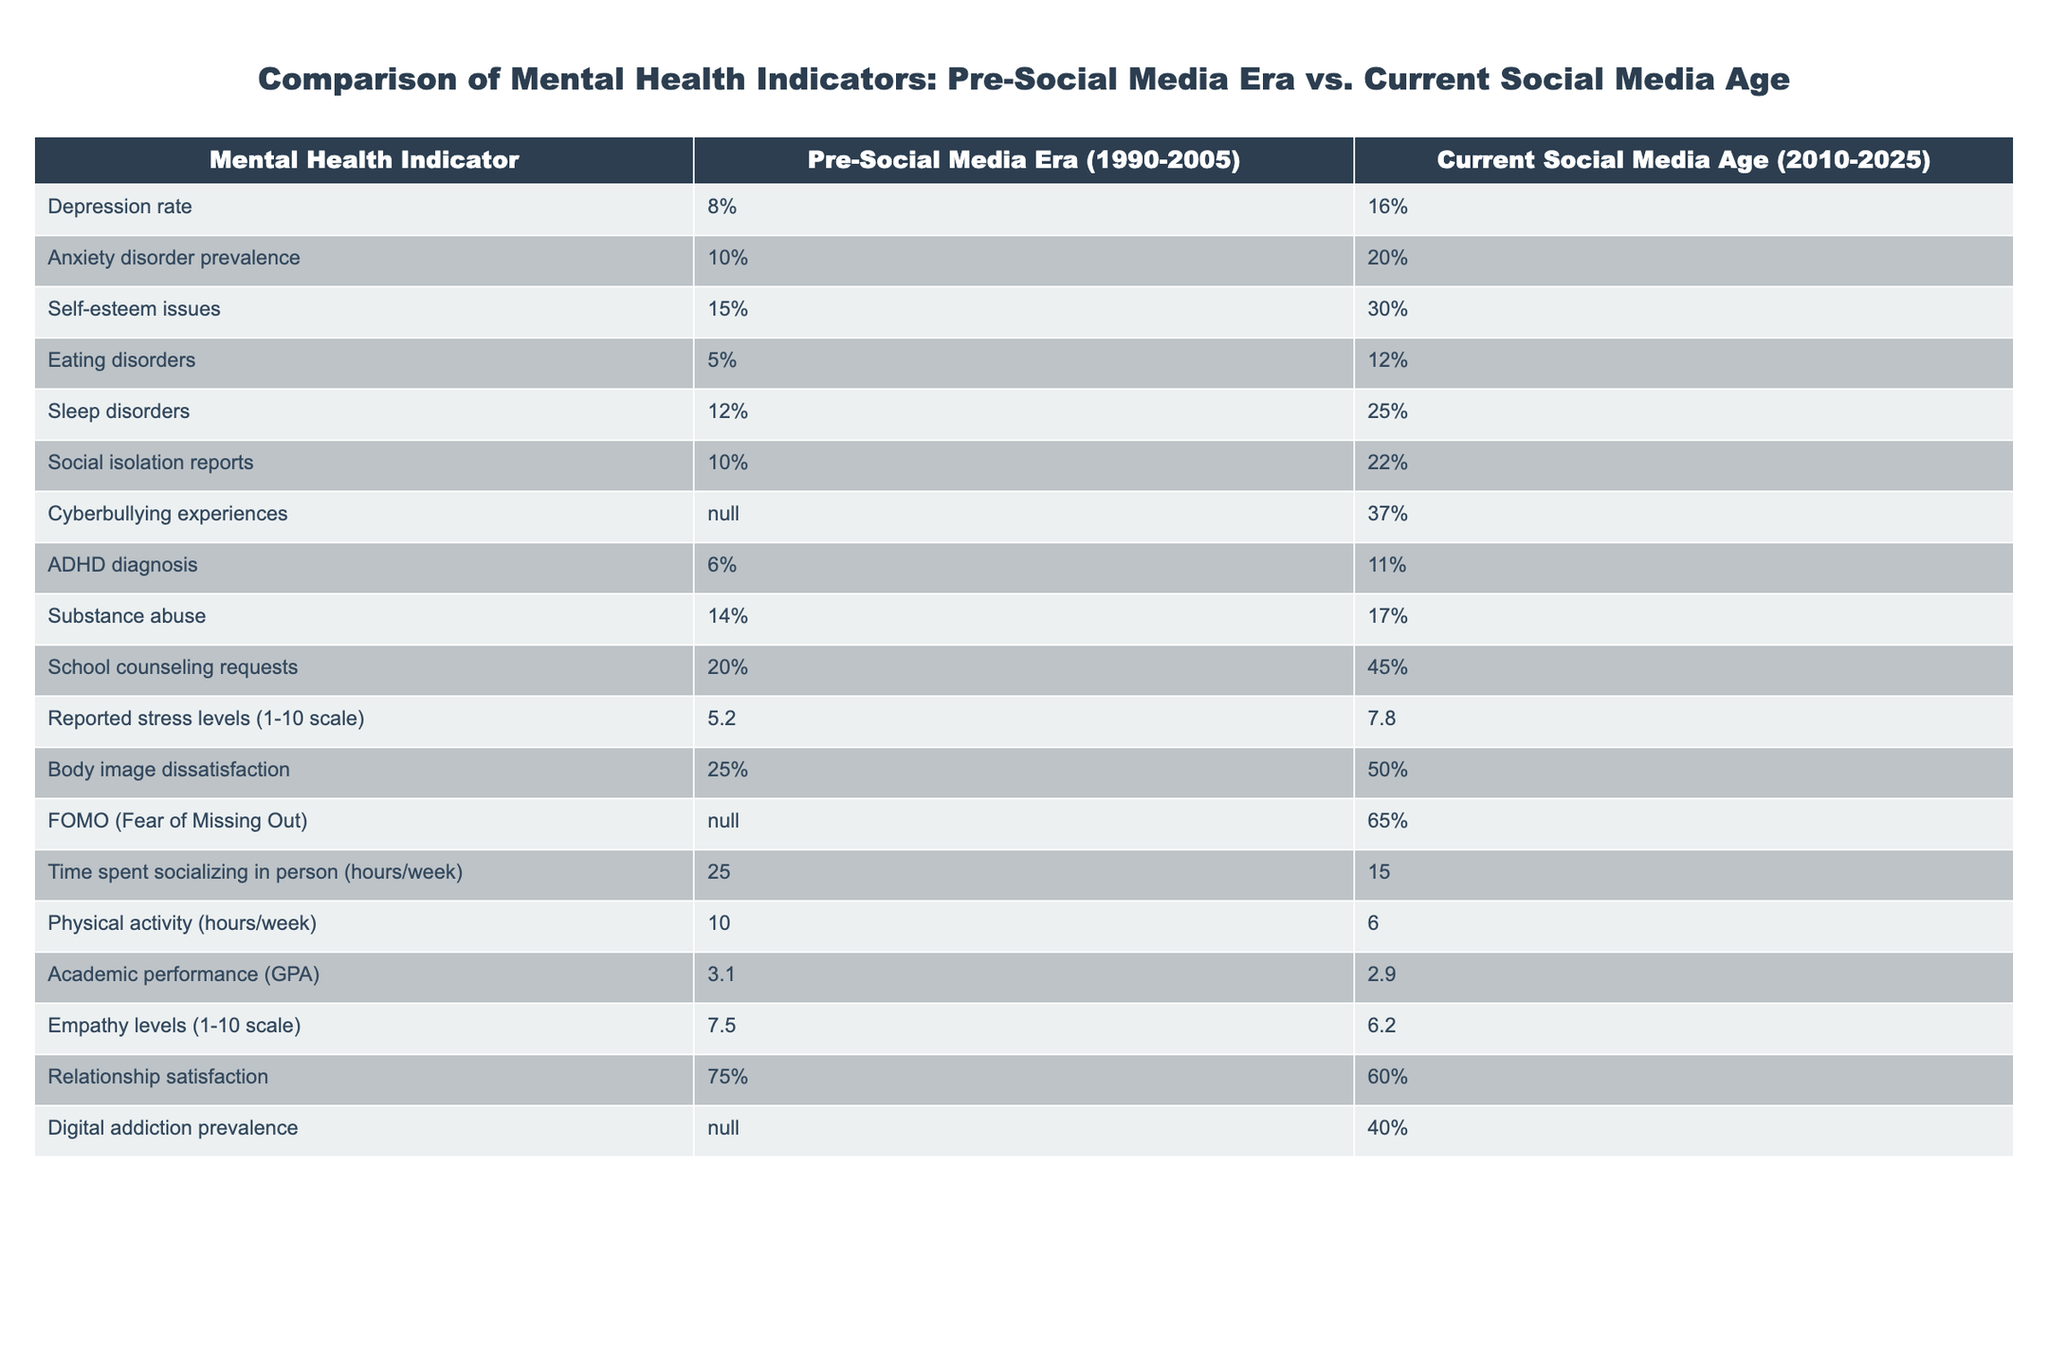What is the depression rate during the current social media age? The table indicates that the depression rate in the current social media age is 16%.
Answer: 16% What percentage of teenagers reported self-esteem issues in the pre-social media era? According to the table, 15% of teenagers reported self-esteem issues during the pre-social media era.
Answer: 15% Is the anxiety disorder prevalence higher in the current social media age compared to the pre-social media era? In the current social media age, the anxiety disorder prevalence is 20%, while in the pre-social media era it was 10%. Therefore, it is higher now.
Answer: Yes What is the difference in sleep disorders percentage between the pre-social media era and the current social media age? The percentage for sleep disorders in the pre-social media era is 12%, while in the current social media age it is 25%. The difference is calculated as 25% - 12% = 13%.
Answer: 13% What is the reported stress level in the current social media age compared to the pre-social media era? The reported stress level during the current social media age is 7.8 on a scale of 1 to 10, whereas in the pre-social media era, it was 5.2. The increase is significant, indicating higher stress levels now.
Answer: 7.8 How many more teenagers requested school counseling in the current social media age compared to the pre-social media era? In the pre-social media era, 20% of teenagers requested counseling, and in the current age, it’s 45%. The difference is 45% - 20% = 25%.
Answer: 25% What are the sleep disorder rates in both eras combined? To find the combined sleep disorder rates, sum the two percentages: 12% (pre-social media) + 25% (current age) = 37%.
Answer: 37% Is cyberbullying reported in the pre-social media era? The table indicates that no data (N/A) is available on cyberbullying experiences from the pre-social media era.
Answer: No What is the average depression rate between the two eras? To find the average, add the two depression rates: 8% (pre-social media) + 16% (current age) = 24%. Then, divide by 2: 24% / 2 = 12%.
Answer: 12% 